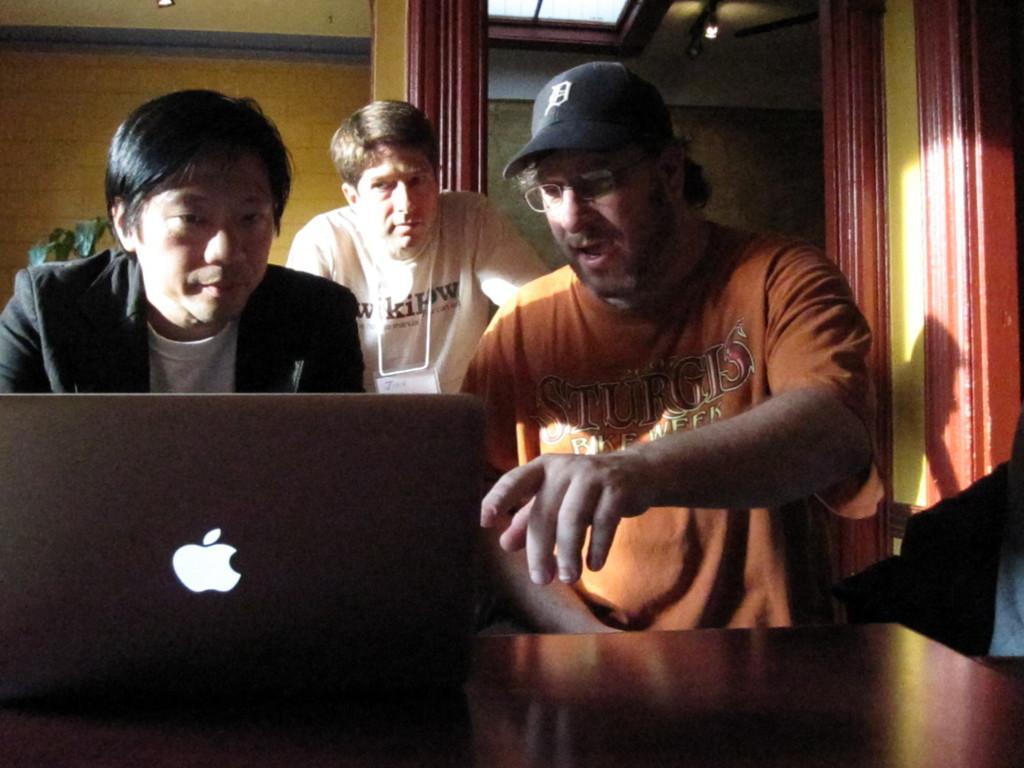Can you describe this image briefly? In this picture I can see three people. I can see the laptop on the table. I can see light arrangements on the roof. 